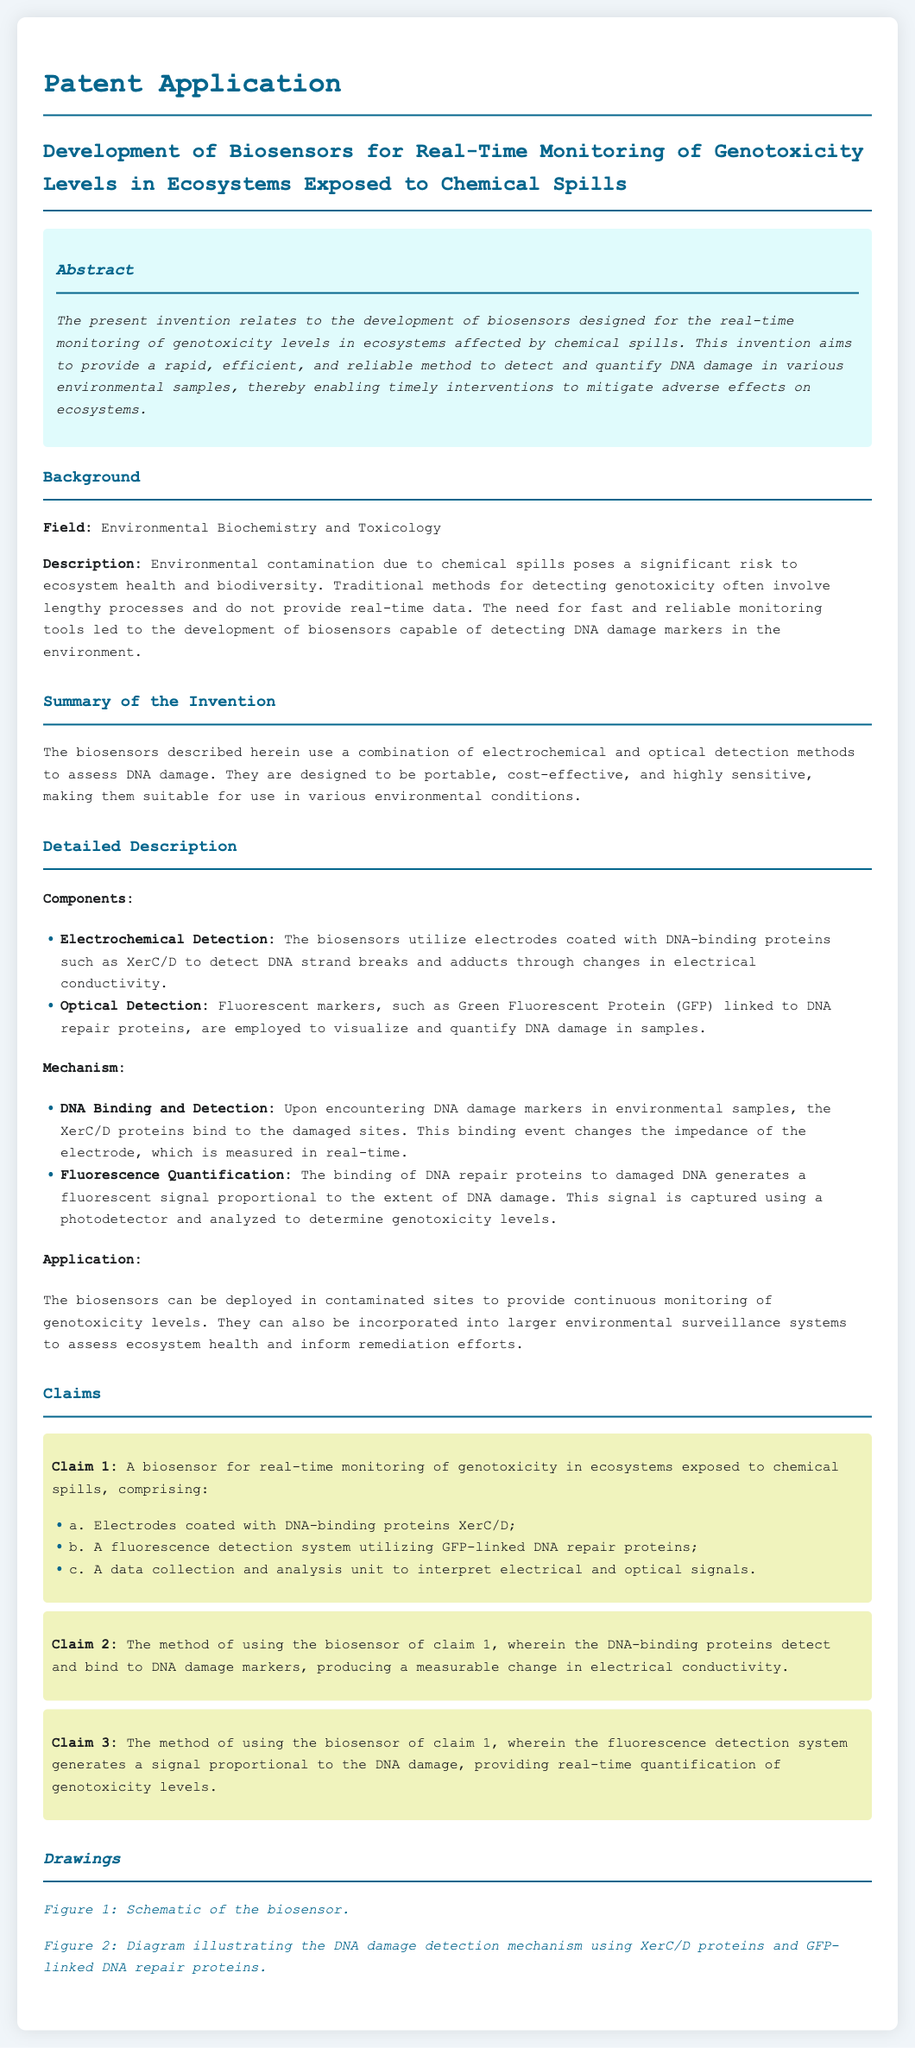What is the title of the invention? The title is the specific term used to describe the subject matter of the patent, which is found at the top of the document.
Answer: Development of Biosensors for Real-Time Monitoring of Genotoxicity Levels in Ecosystems Exposed to Chemical Spills What is the main field of the invention? The field is defined in the background section of the document, outlining the context in which the invention operates.
Answer: Environmental Biochemistry and Toxicology What method is employed for optical detection in the biosensors? The method is explicitly stated in the detailed description of biosensor components within the document.
Answer: Fluorescent markers How many claims are there in the patent application? The number of claims can be determined by counting the listed claims in the claims section of the document.
Answer: Three What type of proteins are used to detect DNA damage? The type of proteins is mentioned in the detailed description under components, specifying their function in DNA detection.
Answer: DNA-binding proteins What is the purpose of the biosensor? The purpose is clearly stated in the abstract, summarizing the overall goal of the invention.
Answer: To detect and quantify DNA damage Which fluorescent protein is mentioned in the document? The specific fluorescent protein is named in the detailed description, linking it to its role in monitoring.
Answer: Green Fluorescent Protein (GFP) What is the expected outcome when DNA damage markers are detected? The expected outcome is detailed in the detailed description, indicating the effect on measurable signals in the biosensor.
Answer: Changes in electrical conductivity What do the biosensors aim to enable regarding ecosystem health? The aim is outlined in the abstract, highlighting the intervention aspect of the technology being developed.
Answer: Timely interventions 